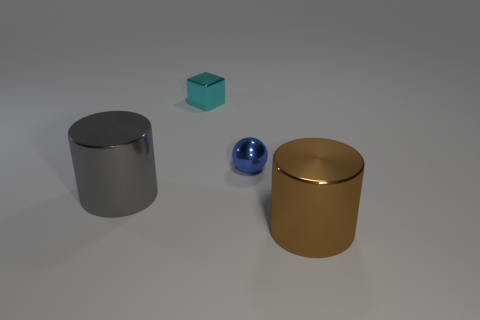What material is the brown thing that is the same size as the gray shiny cylinder?
Your answer should be compact. Metal. There is a big metallic thing to the right of the tiny cyan metallic block; are there any small things that are behind it?
Make the answer very short. Yes. The cyan cube has what size?
Offer a terse response. Small. Are any tiny things visible?
Keep it short and to the point. Yes. Are there more cyan blocks behind the metal block than cylinders that are on the left side of the brown metal cylinder?
Your answer should be compact. No. There is a thing that is on the left side of the tiny blue sphere and in front of the small cube; what material is it?
Your answer should be very brief. Metal. Does the big brown thing have the same shape as the cyan thing?
Offer a very short reply. No. Is there any other thing that has the same size as the gray cylinder?
Offer a terse response. Yes. There is a cyan block; what number of objects are in front of it?
Make the answer very short. 3. There is a metallic thing that is in front of the gray thing; is its size the same as the blue metallic sphere?
Your response must be concise. No. 